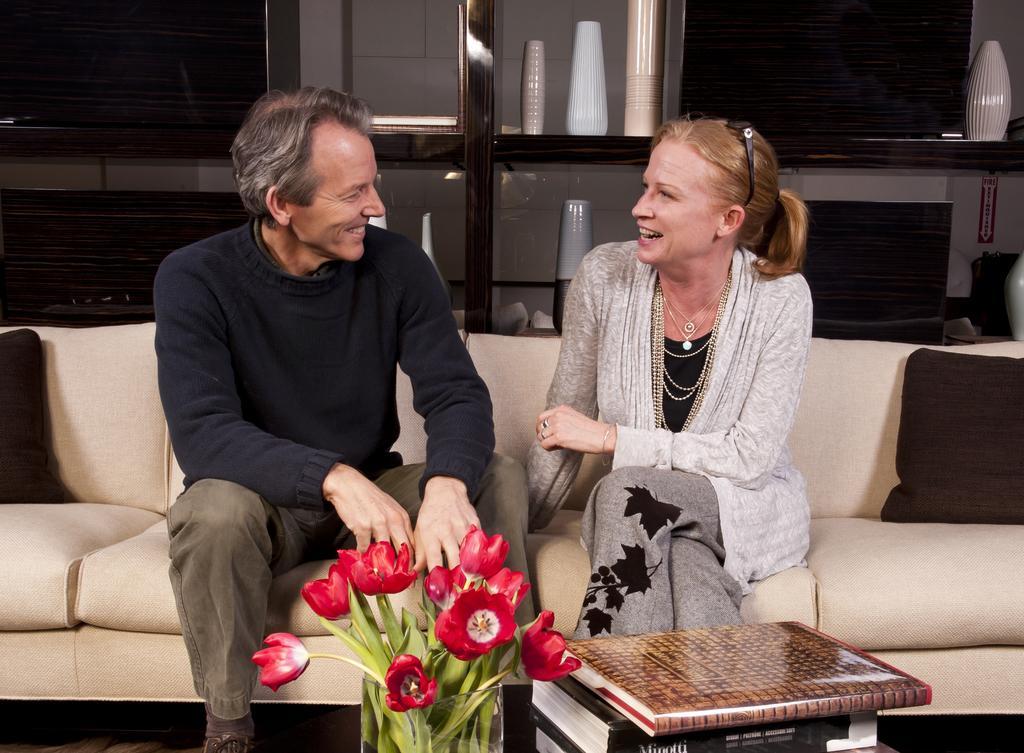Could you give a brief overview of what you see in this image? In this picture there is a man and woman sitting on couch. They are smiling. In front of them there is a table and on it there is a flower vase and books are placed. Behind them there is a wooden cupboard and it things are placed. 